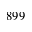Convert formula to latex. <formula><loc_0><loc_0><loc_500><loc_500>8 9 9</formula> 